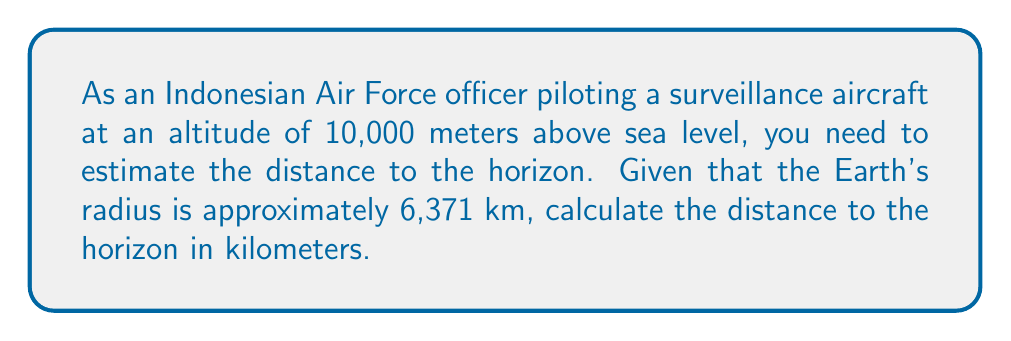Can you answer this question? To solve this problem, we'll use the formula for the distance to the horizon from a given altitude. Let's break it down step-by-step:

1. The formula for the distance to the horizon is:

   $$d = \sqrt{2Rh + h^2}$$

   Where:
   $d$ is the distance to the horizon
   $R$ is the Earth's radius
   $h$ is the height above the Earth's surface

2. We're given:
   $R = 6,371$ km
   $h = 10$ km (10,000 meters converted to kilometers)

3. Let's substitute these values into the formula:

   $$d = \sqrt{2 \cdot 6,371 \cdot 10 + 10^2}$$

4. Simplify inside the square root:

   $$d = \sqrt{127,420 + 100}$$
   $$d = \sqrt{127,520}$$

5. Calculate the square root:

   $$d \approx 357.10$$ km

Therefore, the distance to the horizon from an altitude of 10,000 meters is approximately 357.10 kilometers.
Answer: 357.10 km 